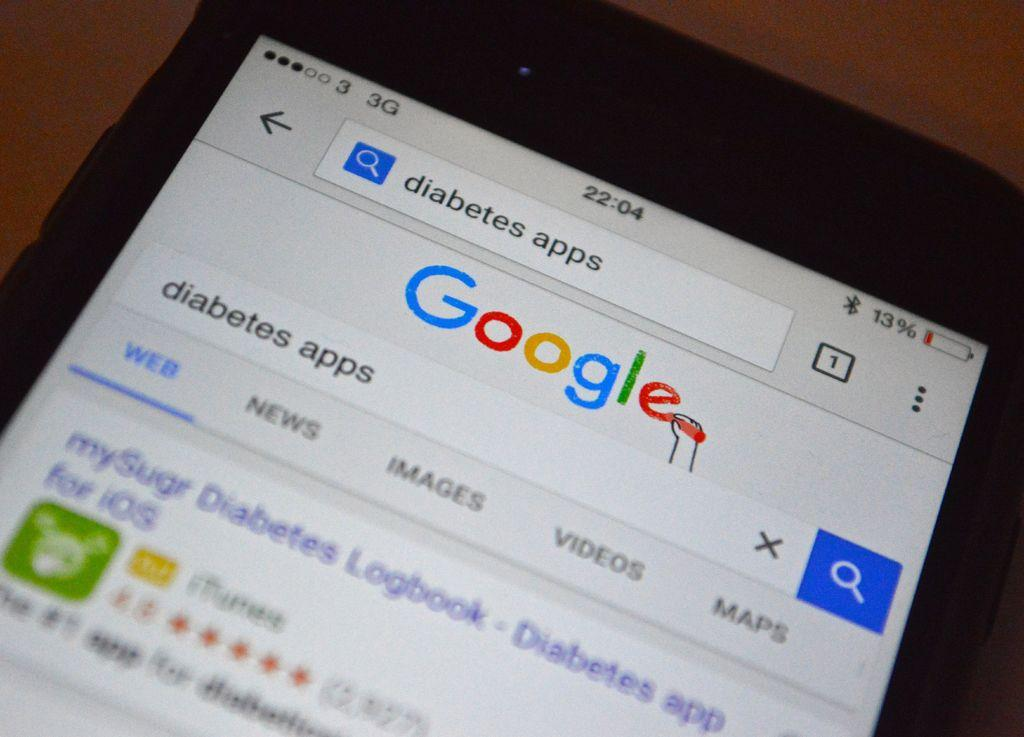Provide a one-sentence caption for the provided image. A phone showing, Google looking for diabetes app in the search bar. 